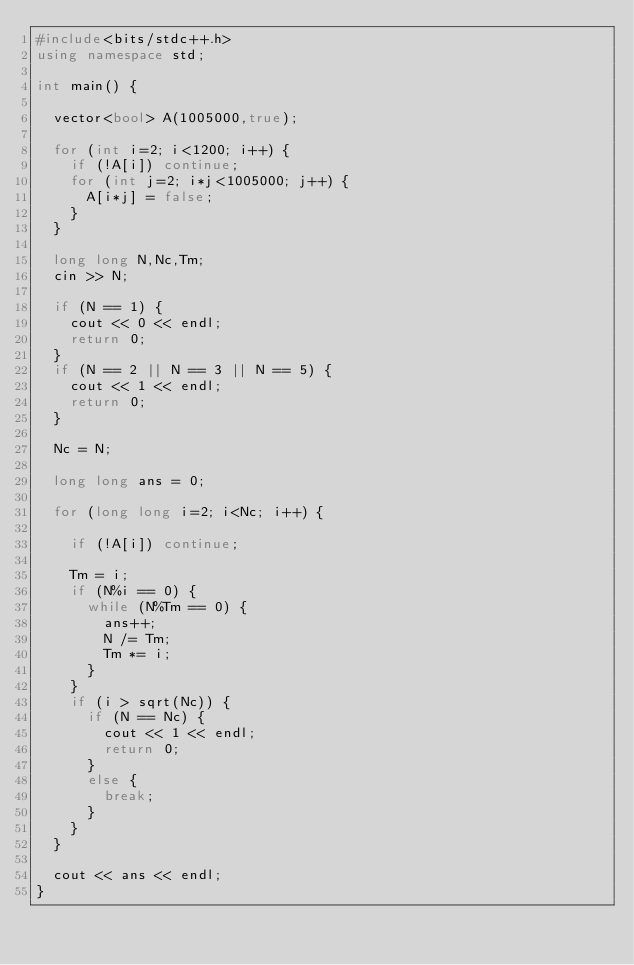<code> <loc_0><loc_0><loc_500><loc_500><_C++_>#include<bits/stdc++.h>
using namespace std;

int main() {
  
  vector<bool> A(1005000,true);
  
  for (int i=2; i<1200; i++) {
    if (!A[i]) continue;
    for (int j=2; i*j<1005000; j++) {
      A[i*j] = false;
    }
  }
  
  long long N,Nc,Tm;
  cin >> N;
  
  if (N == 1) {
    cout << 0 << endl;
    return 0;
  }
  if (N == 2 || N == 3 || N == 5) {
    cout << 1 << endl;
    return 0;
  }
  
  Nc = N;
  
  long long ans = 0;
  
  for (long long i=2; i<Nc; i++) {
    
    if (!A[i]) continue;
    
    Tm = i;
    if (N%i == 0) {
      while (N%Tm == 0) {
        ans++;
        N /= Tm;
        Tm *= i;
      }
    }
    if (i > sqrt(Nc)) {
      if (N == Nc) {
        cout << 1 << endl;
        return 0;
      }
      else {
        break;
      }
    }
  }
  
  cout << ans << endl;
}</code> 